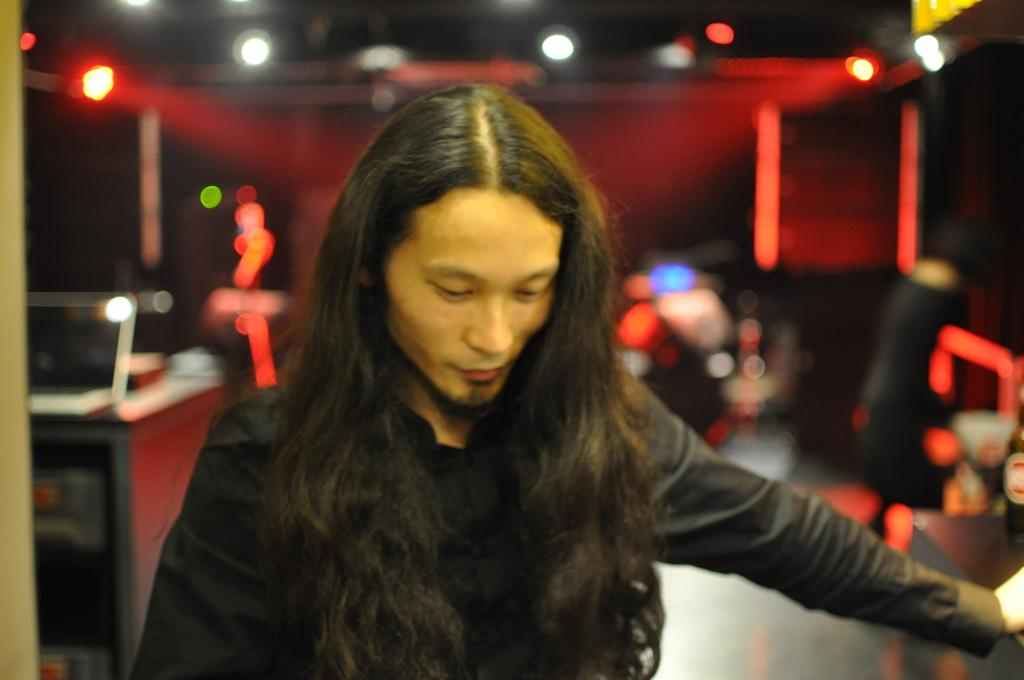What is the main subject in the foreground of the picture? There is a person in the foreground of the picture. What can be seen in the background of the image? In the background, there are lights visible, but the image is blurred. What type of beetle can be seen crawling on the person's shoulder in the image? There is no beetle visible on the person's shoulder in the image. What type of art is being created in the image? The image does not depict any art being created. 